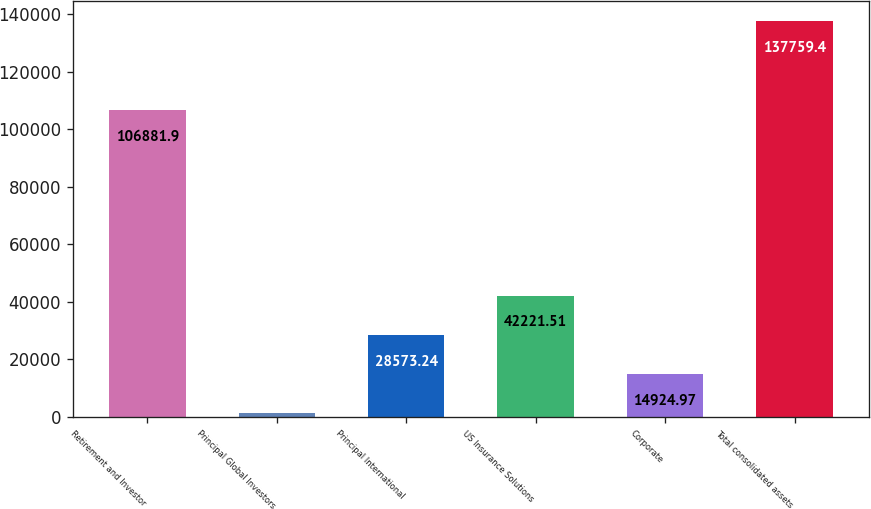Convert chart. <chart><loc_0><loc_0><loc_500><loc_500><bar_chart><fcel>Retirement and Investor<fcel>Principal Global Investors<fcel>Principal International<fcel>US Insurance Solutions<fcel>Corporate<fcel>Total consolidated assets<nl><fcel>106882<fcel>1276.7<fcel>28573.2<fcel>42221.5<fcel>14925<fcel>137759<nl></chart> 